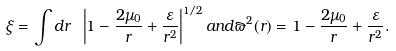<formula> <loc_0><loc_0><loc_500><loc_500>\xi = \int d r \ \left | 1 - \frac { 2 \mu _ { 0 } } { r } + \frac { \varepsilon } { r ^ { 2 } } \right | ^ { 1 / 2 } a n d \varpi ^ { 2 } ( r ) = 1 - \frac { 2 \mu _ { 0 } } { r } + \frac { \varepsilon } { r ^ { 2 } } .</formula> 